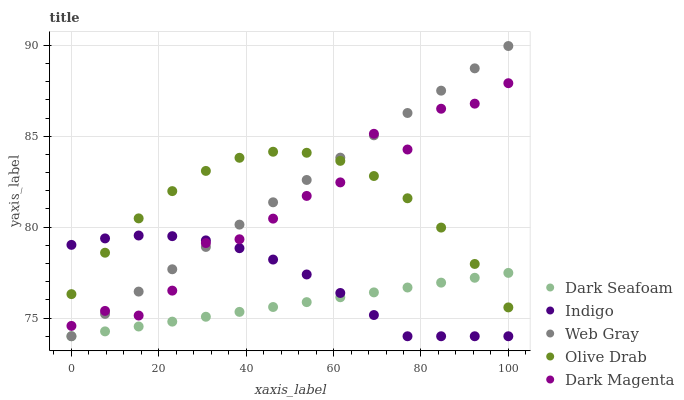Does Dark Seafoam have the minimum area under the curve?
Answer yes or no. Yes. Does Web Gray have the maximum area under the curve?
Answer yes or no. Yes. Does Indigo have the minimum area under the curve?
Answer yes or no. No. Does Indigo have the maximum area under the curve?
Answer yes or no. No. Is Dark Seafoam the smoothest?
Answer yes or no. Yes. Is Dark Magenta the roughest?
Answer yes or no. Yes. Is Web Gray the smoothest?
Answer yes or no. No. Is Web Gray the roughest?
Answer yes or no. No. Does Dark Seafoam have the lowest value?
Answer yes or no. Yes. Does Dark Magenta have the lowest value?
Answer yes or no. No. Does Web Gray have the highest value?
Answer yes or no. Yes. Does Indigo have the highest value?
Answer yes or no. No. Is Dark Seafoam less than Dark Magenta?
Answer yes or no. Yes. Is Dark Magenta greater than Dark Seafoam?
Answer yes or no. Yes. Does Dark Seafoam intersect Web Gray?
Answer yes or no. Yes. Is Dark Seafoam less than Web Gray?
Answer yes or no. No. Is Dark Seafoam greater than Web Gray?
Answer yes or no. No. Does Dark Seafoam intersect Dark Magenta?
Answer yes or no. No. 